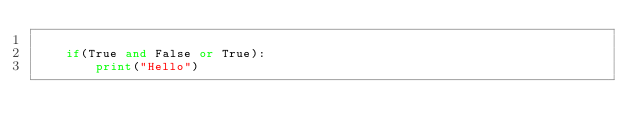Convert code to text. <code><loc_0><loc_0><loc_500><loc_500><_Python_>
    if(True and False or True):
        print("Hello")</code> 